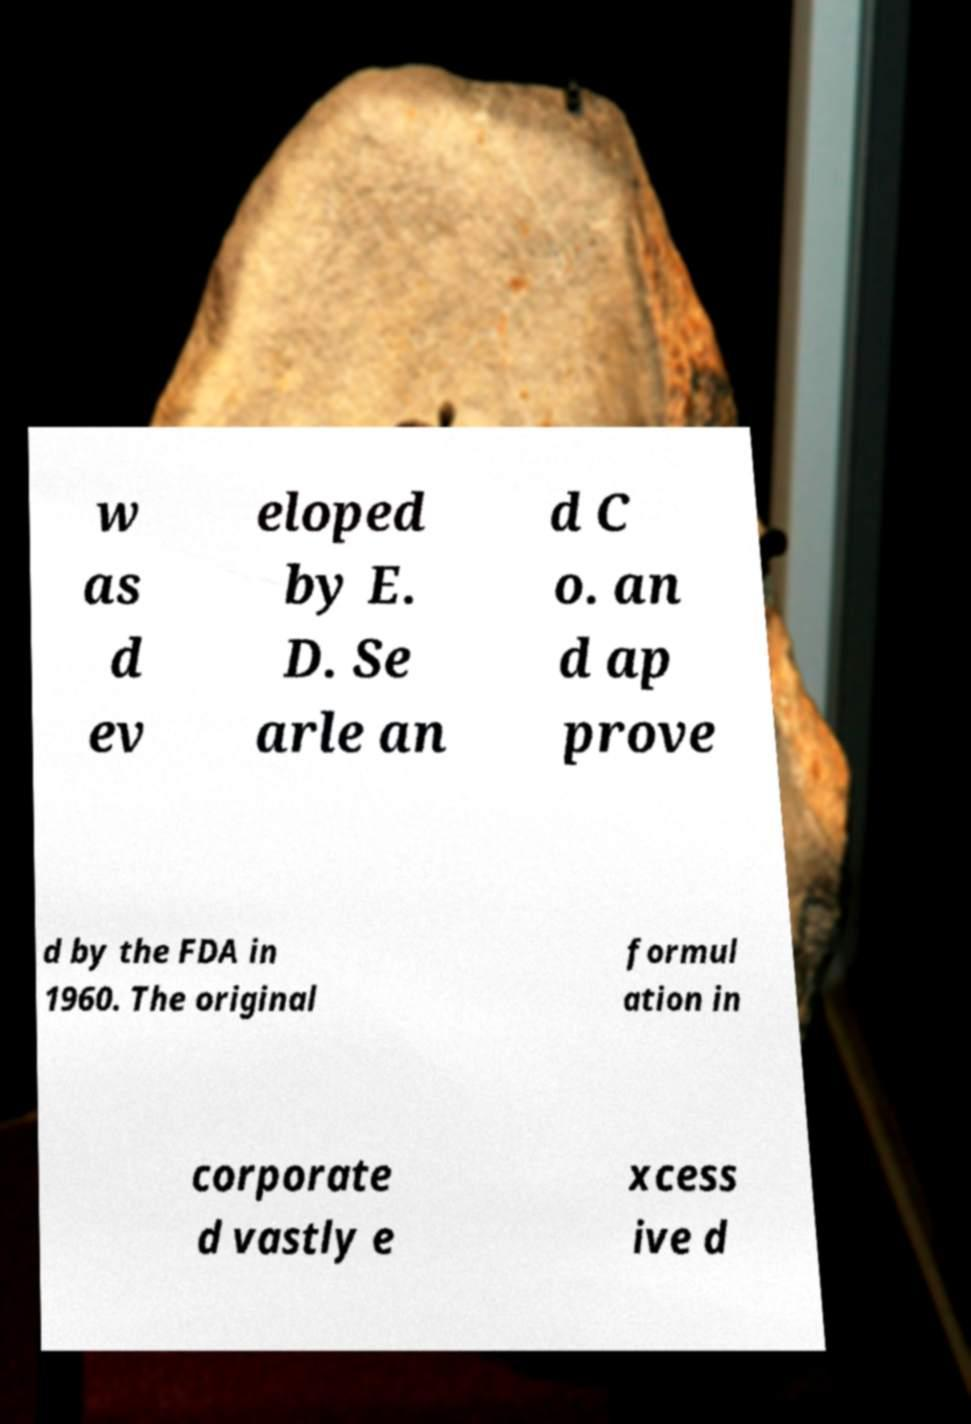Could you assist in decoding the text presented in this image and type it out clearly? w as d ev eloped by E. D. Se arle an d C o. an d ap prove d by the FDA in 1960. The original formul ation in corporate d vastly e xcess ive d 